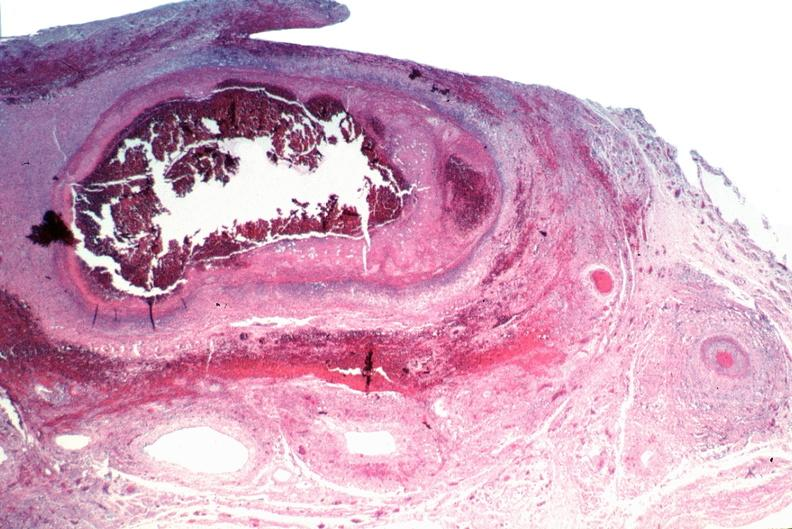what does this image show?
Answer the question using a single word or phrase. Vasculitis 